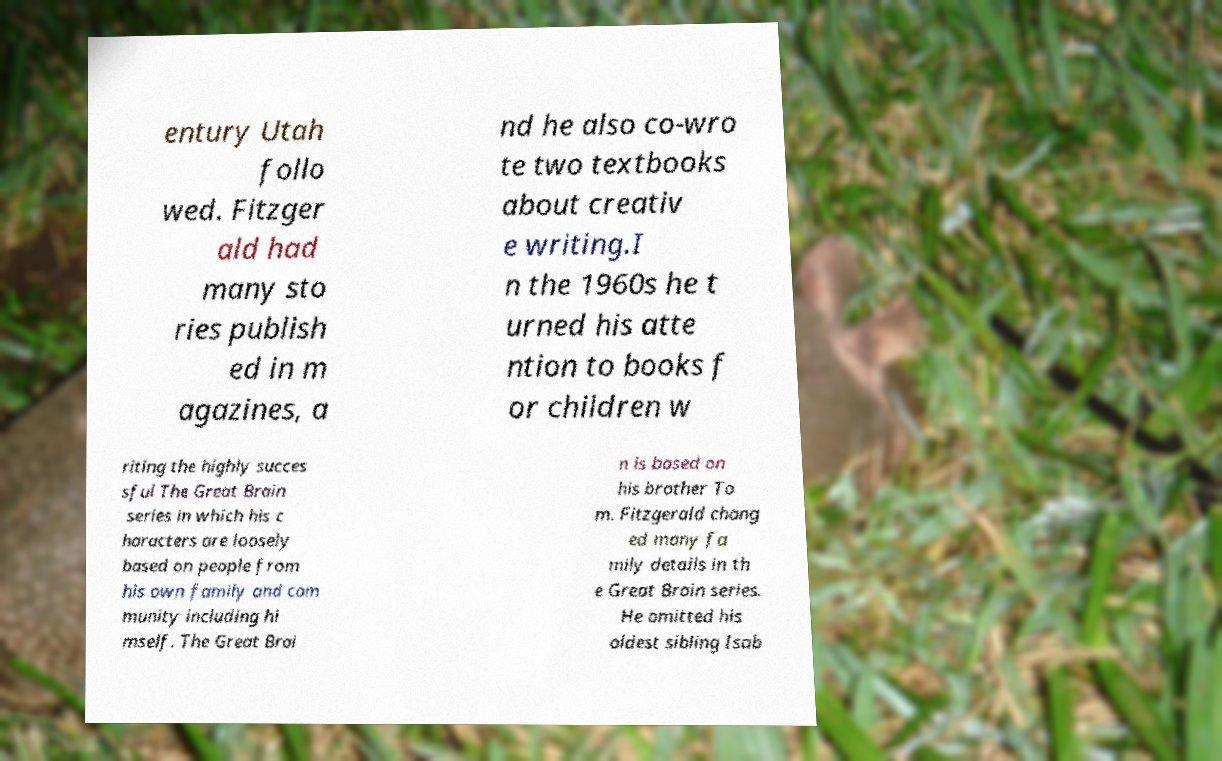I need the written content from this picture converted into text. Can you do that? entury Utah follo wed. Fitzger ald had many sto ries publish ed in m agazines, a nd he also co-wro te two textbooks about creativ e writing.I n the 1960s he t urned his atte ntion to books f or children w riting the highly succes sful The Great Brain series in which his c haracters are loosely based on people from his own family and com munity including hi mself. The Great Brai n is based on his brother To m. Fitzgerald chang ed many fa mily details in th e Great Brain series. He omitted his oldest sibling Isab 